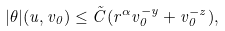<formula> <loc_0><loc_0><loc_500><loc_500>| \theta | ( u , v _ { 0 } ) \leq \tilde { C } ( r ^ { \alpha } v _ { 0 } ^ { - y } + v _ { 0 } ^ { - z } ) ,</formula> 